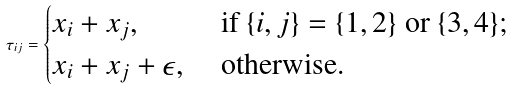<formula> <loc_0><loc_0><loc_500><loc_500>\tau _ { i j } = \begin{cases} x _ { i } + x _ { j } , & \text { if } \{ i , j \} = \{ 1 , 2 \} \text { or } \{ 3 , 4 \} ; \\ x _ { i } + x _ { j } + \epsilon , & \text { otherwise.} \end{cases}</formula> 